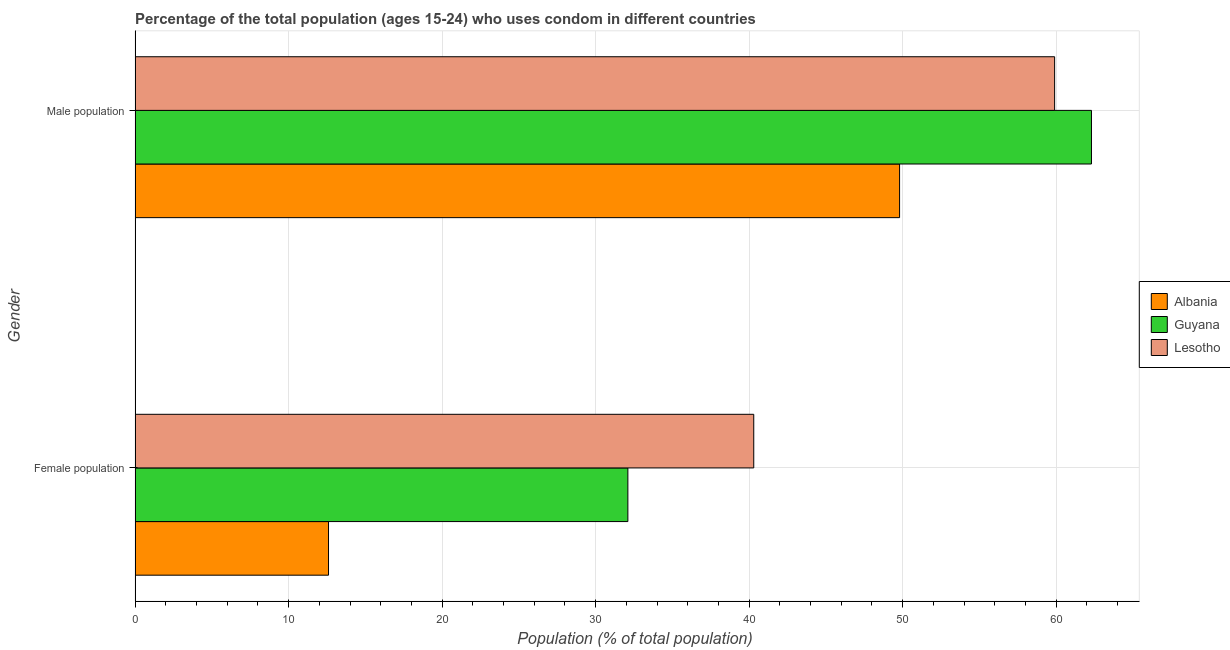How many different coloured bars are there?
Provide a succinct answer. 3. How many groups of bars are there?
Your response must be concise. 2. Are the number of bars on each tick of the Y-axis equal?
Ensure brevity in your answer.  Yes. How many bars are there on the 2nd tick from the bottom?
Offer a terse response. 3. What is the label of the 1st group of bars from the top?
Provide a short and direct response. Male population. What is the female population in Lesotho?
Your response must be concise. 40.3. Across all countries, what is the maximum male population?
Your answer should be very brief. 62.3. Across all countries, what is the minimum male population?
Provide a short and direct response. 49.8. In which country was the male population maximum?
Keep it short and to the point. Guyana. In which country was the male population minimum?
Give a very brief answer. Albania. What is the difference between the female population in Lesotho and that in Guyana?
Keep it short and to the point. 8.2. What is the difference between the male population in Guyana and the female population in Albania?
Your answer should be very brief. 49.7. What is the average male population per country?
Make the answer very short. 57.33. What is the difference between the female population and male population in Guyana?
Offer a terse response. -30.2. In how many countries, is the female population greater than 10 %?
Make the answer very short. 3. What is the ratio of the male population in Guyana to that in Lesotho?
Provide a short and direct response. 1.04. In how many countries, is the male population greater than the average male population taken over all countries?
Your answer should be compact. 2. What does the 2nd bar from the top in Female population represents?
Make the answer very short. Guyana. What does the 2nd bar from the bottom in Male population represents?
Your answer should be compact. Guyana. How many countries are there in the graph?
Your response must be concise. 3. Are the values on the major ticks of X-axis written in scientific E-notation?
Make the answer very short. No. Does the graph contain any zero values?
Provide a succinct answer. No. How many legend labels are there?
Your answer should be very brief. 3. What is the title of the graph?
Provide a short and direct response. Percentage of the total population (ages 15-24) who uses condom in different countries. Does "Niger" appear as one of the legend labels in the graph?
Make the answer very short. No. What is the label or title of the X-axis?
Offer a very short reply. Population (% of total population) . What is the label or title of the Y-axis?
Your answer should be compact. Gender. What is the Population (% of total population)  of Guyana in Female population?
Provide a short and direct response. 32.1. What is the Population (% of total population)  of Lesotho in Female population?
Your response must be concise. 40.3. What is the Population (% of total population)  of Albania in Male population?
Offer a very short reply. 49.8. What is the Population (% of total population)  in Guyana in Male population?
Your answer should be very brief. 62.3. What is the Population (% of total population)  in Lesotho in Male population?
Your answer should be very brief. 59.9. Across all Gender, what is the maximum Population (% of total population)  of Albania?
Offer a very short reply. 49.8. Across all Gender, what is the maximum Population (% of total population)  of Guyana?
Keep it short and to the point. 62.3. Across all Gender, what is the maximum Population (% of total population)  in Lesotho?
Provide a succinct answer. 59.9. Across all Gender, what is the minimum Population (% of total population)  in Guyana?
Provide a succinct answer. 32.1. Across all Gender, what is the minimum Population (% of total population)  in Lesotho?
Provide a succinct answer. 40.3. What is the total Population (% of total population)  of Albania in the graph?
Give a very brief answer. 62.4. What is the total Population (% of total population)  of Guyana in the graph?
Keep it short and to the point. 94.4. What is the total Population (% of total population)  in Lesotho in the graph?
Offer a terse response. 100.2. What is the difference between the Population (% of total population)  of Albania in Female population and that in Male population?
Offer a terse response. -37.2. What is the difference between the Population (% of total population)  in Guyana in Female population and that in Male population?
Give a very brief answer. -30.2. What is the difference between the Population (% of total population)  in Lesotho in Female population and that in Male population?
Provide a succinct answer. -19.6. What is the difference between the Population (% of total population)  in Albania in Female population and the Population (% of total population)  in Guyana in Male population?
Ensure brevity in your answer.  -49.7. What is the difference between the Population (% of total population)  in Albania in Female population and the Population (% of total population)  in Lesotho in Male population?
Make the answer very short. -47.3. What is the difference between the Population (% of total population)  in Guyana in Female population and the Population (% of total population)  in Lesotho in Male population?
Your response must be concise. -27.8. What is the average Population (% of total population)  of Albania per Gender?
Offer a terse response. 31.2. What is the average Population (% of total population)  in Guyana per Gender?
Keep it short and to the point. 47.2. What is the average Population (% of total population)  of Lesotho per Gender?
Give a very brief answer. 50.1. What is the difference between the Population (% of total population)  in Albania and Population (% of total population)  in Guyana in Female population?
Provide a succinct answer. -19.5. What is the difference between the Population (% of total population)  in Albania and Population (% of total population)  in Lesotho in Female population?
Your answer should be very brief. -27.7. What is the difference between the Population (% of total population)  of Albania and Population (% of total population)  of Lesotho in Male population?
Your answer should be very brief. -10.1. What is the ratio of the Population (% of total population)  in Albania in Female population to that in Male population?
Offer a very short reply. 0.25. What is the ratio of the Population (% of total population)  in Guyana in Female population to that in Male population?
Your answer should be compact. 0.52. What is the ratio of the Population (% of total population)  in Lesotho in Female population to that in Male population?
Make the answer very short. 0.67. What is the difference between the highest and the second highest Population (% of total population)  of Albania?
Keep it short and to the point. 37.2. What is the difference between the highest and the second highest Population (% of total population)  in Guyana?
Offer a terse response. 30.2. What is the difference between the highest and the second highest Population (% of total population)  of Lesotho?
Provide a succinct answer. 19.6. What is the difference between the highest and the lowest Population (% of total population)  in Albania?
Provide a succinct answer. 37.2. What is the difference between the highest and the lowest Population (% of total population)  of Guyana?
Your answer should be very brief. 30.2. What is the difference between the highest and the lowest Population (% of total population)  in Lesotho?
Provide a succinct answer. 19.6. 